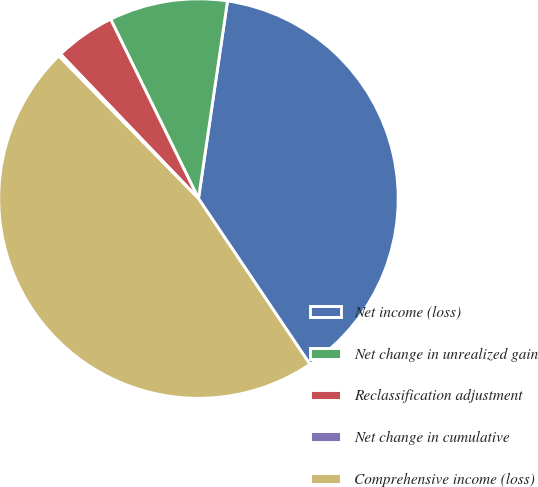<chart> <loc_0><loc_0><loc_500><loc_500><pie_chart><fcel>Net income (loss)<fcel>Net change in unrealized gain<fcel>Reclassification adjustment<fcel>Net change in cumulative<fcel>Comprehensive income (loss)<nl><fcel>38.26%<fcel>9.57%<fcel>4.89%<fcel>0.2%<fcel>47.09%<nl></chart> 